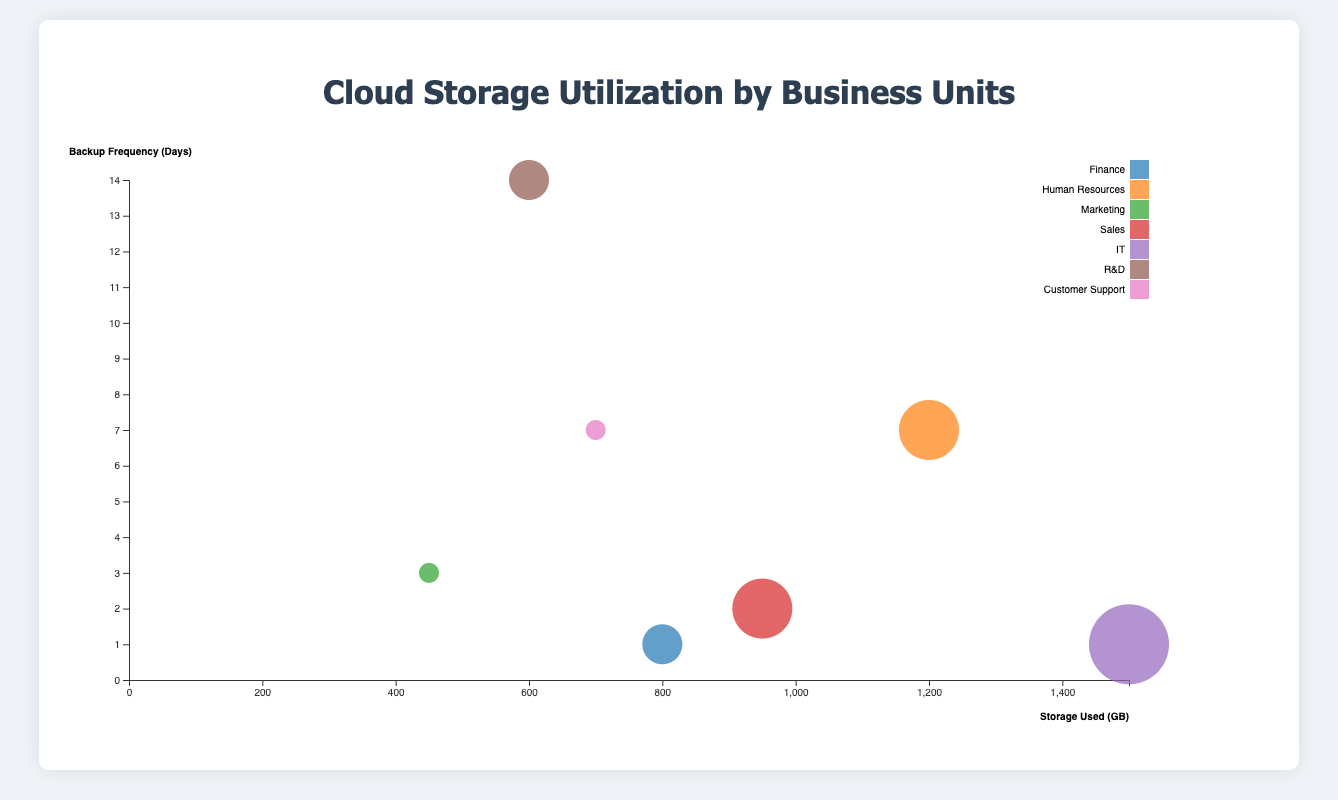What's the title of the chart? The title of the chart is clearly mentioned at the top of the figure, displaying the purpose of the visualization. It's "Cloud Storage Utilization by Business Units".
Answer: Cloud Storage Utilization by Business Units How many business units are displayed in the chart? Each business unit is represented by a different bubble. Counting these bubbles or referring to the legend will provide the number of business units. There are 7 business units listed.
Answer: 7 Which business unit has the highest storage utilization? By observing the x-axis and identifying the bubble farthest to the right, you can see that the IT business unit has the highest storage utilization. IT is at 1500 GB.
Answer: IT What is the backup frequency of the Sales business unit? By locating the Sales business unit bubble on the chart and observing its position on the y-axis, you can see that the backup frequency for Sales is 2 days.
Answer: 2 days Which business unit has the lowest redundancy level, and how much storage does it use? By examining the size of the bubbles, you can identify that smaller bubbles correspond to the lowest redundancy levels. Marketing and Customer Support have the smallest bubbles with a redundancy level of 1. Marketing uses 450 GB and Customer Support uses 700 GB.
Answer: Marketing and Customer Support; 450 GB and 700 GB How many business units have a redundancy level of 2? The size of the bubbles correlates with the redundancy levels. By counting the bubbles that match the size indicating a redundancy level of 2, you find Finance and R&D.
Answer: 2 Which business unit backs up data most frequently? By finding the bubble closest to the bottom on the y-axis, you see that the Finance and IT business units have the shortest backup frequency of 1 day.
Answer: Finance and IT Compare the storage used by Finance and Sales. Which uses more? By locating the Finance and Sales bubbles along the x-axis, it is evident that Finance uses 800 GB and Sales uses 950 GB, making sales the business unit that uses more storage.
Answer: Sales What is the average storage used by all business units? Sum up the storage used by all business units (800 + 1200 + 450 + 950 + 1500 + 600 + 700 = 6200 GB) and divide by the number of business units (7). The average is 6200 / 7.
Answer: 885.71 GB Which two business units have the same backup frequency and what is it? By examining the y-axis positions, you'll see that Human Resources and Customer Support both have backup frequencies of 7 days.
Answer: Human Resources and Customer Support, 7 days 